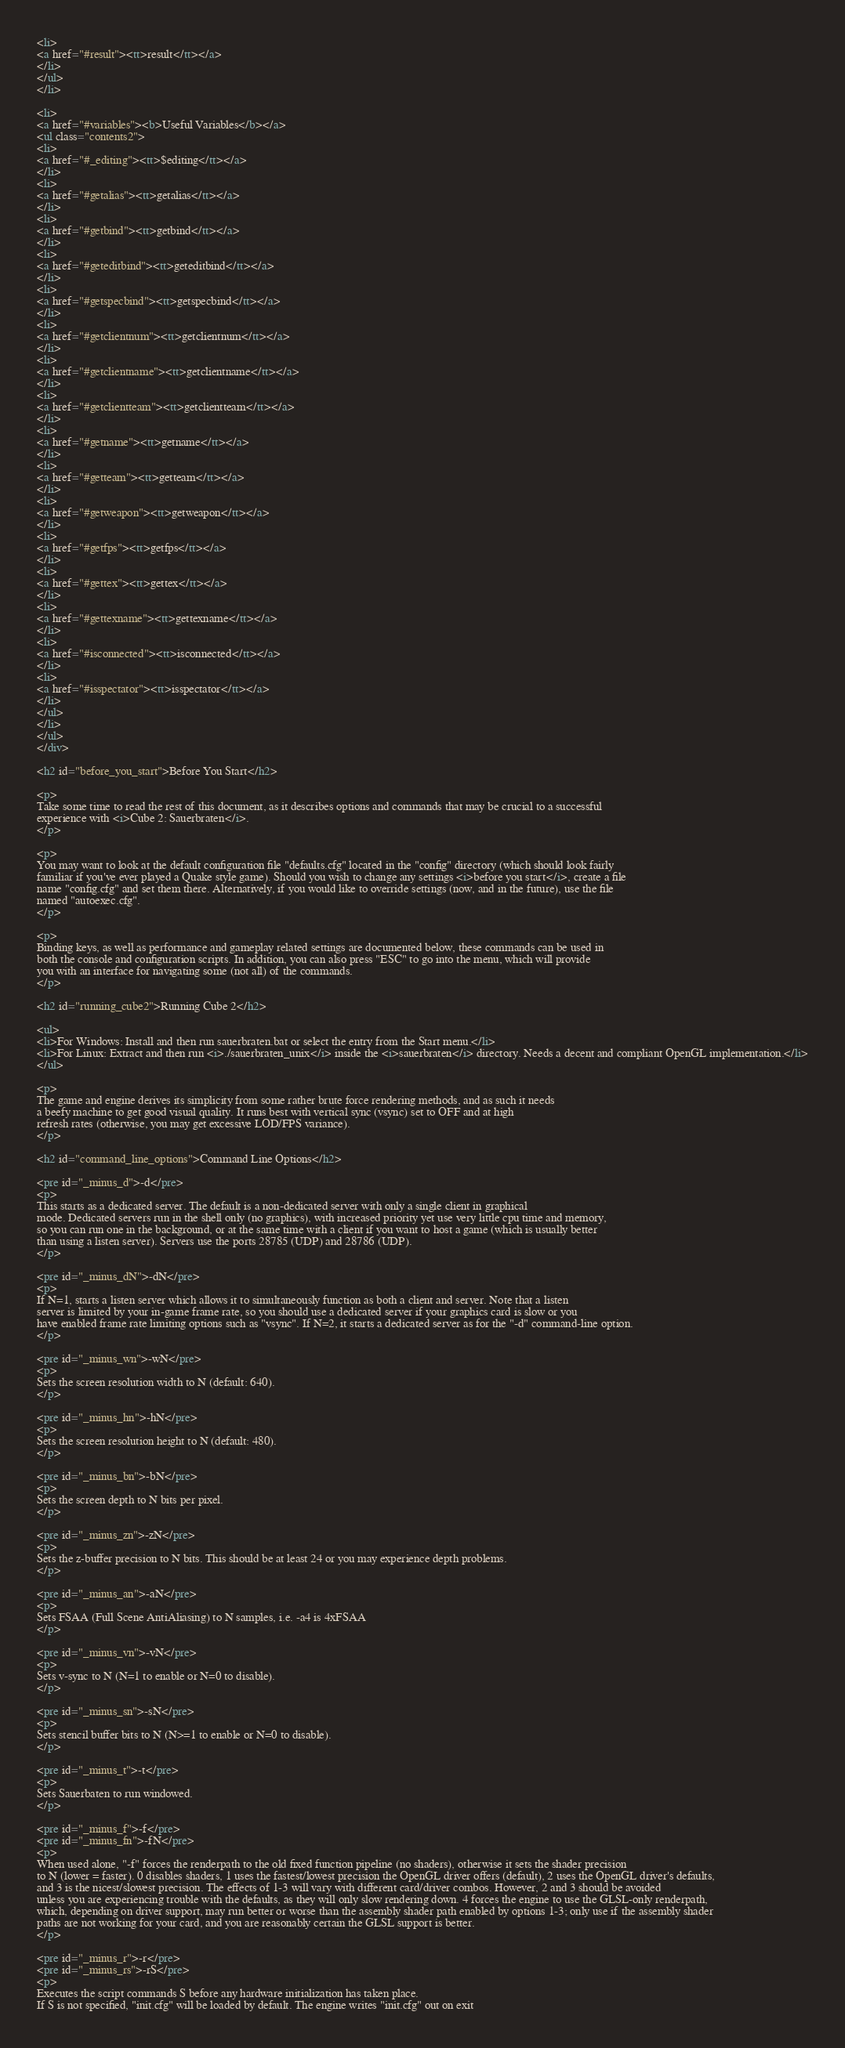Convert code to text. <code><loc_0><loc_0><loc_500><loc_500><_HTML_><li>
<a href="#result"><tt>result</tt></a>
</li>
</ul>
</li>

<li>
<a href="#variables"><b>Useful Variables</b></a>
<ul class="contents2">
<li>
<a href="#_editing"><tt>$editing</tt></a>
</li>
<li>
<a href="#getalias"><tt>getalias</tt></a>
</li>
<li>
<a href="#getbind"><tt>getbind</tt></a>
</li>
<li>
<a href="#geteditbind"><tt>geteditbind</tt></a>
</li>
<li>
<a href="#getspecbind"><tt>getspecbind</tt></a>
</li>
<li>
<a href="#getclientnum"><tt>getclientnum</tt></a>
</li>
<li>
<a href="#getclientname"><tt>getclientname</tt></a>
</li>
<li>
<a href="#getclientteam"><tt>getclientteam</tt></a>
</li>
<li>
<a href="#getname"><tt>getname</tt></a>
</li>
<li>
<a href="#getteam"><tt>getteam</tt></a>
</li>
<li>
<a href="#getweapon"><tt>getweapon</tt></a>
</li>
<li>
<a href="#getfps"><tt>getfps</tt></a>
</li>
<li>
<a href="#gettex"><tt>gettex</tt></a>
</li>
<li>
<a href="#gettexname"><tt>gettexname</tt></a>
</li>
<li>
<a href="#isconnected"><tt>isconnected</tt></a>
</li>
<li>
<a href="#isspectator"><tt>isspectator</tt></a>
</li>
</ul>
</li>
</ul>
</div>

<h2 id="before_you_start">Before You Start</h2>

<p>
Take some time to read the rest of this document, as it describes options and commands that may be crucial to a successful
experience with <i>Cube 2: Sauerbraten</i>.
</p>

<p>
You may want to look at the default configuration file "defaults.cfg" located in the "config" directory (which should look fairly
familiar if you've ever played a Quake style game). Should you wish to change any settings <i>before you start</i>, create a file
name "config.cfg" and set them there. Alternatively, if you would like to override settings (now, and in the future), use the file
named "autoexec.cfg".
</p>

<p>
Binding keys, as well as performance and gameplay related settings are documented below, these commands can be used in
both the console and configuration scripts. In addition, you can also press "ESC" to go into the menu, which will provide
you with an interface for navigating some (not all) of the commands.
</p>

<h2 id="running_cube2">Running Cube 2</h2>

<ul>
<li>For Windows: Install and then run sauerbraten.bat or select the entry from the Start menu.</li>
<li>For Linux: Extract and then run <i>./sauerbraten_unix</i> inside the <i>sauerbraten</i> directory. Needs a decent and compliant OpenGL implementation.</li>
</ul>

<p>
The game and engine derives its simplicity from some rather brute force rendering methods, and as such it needs 
a beefy machine to get good visual quality. It runs best with vertical sync (vsync) set to OFF and at high
refresh rates (otherwise, you may get excessive LOD/FPS variance).
</p>

<h2 id="command_line_options">Command Line Options</h2>

<pre id="_minus_d">-d</pre>
<p>
This starts as a dedicated server. The default is a non-dedicated server with only a single client in graphical
mode. Dedicated servers run in the shell only (no graphics), with increased priority yet use very little cpu time and memory,
so you can run one in the background, or at the same time with a client if you want to host a game (which is usually better 
than using a listen server). Servers use the ports 28785 (UDP) and 28786 (UDP).
</p>

<pre id="_minus_dN">-dN</pre>
<p>
If N=1, starts a listen server which allows it to simultaneously function as both a client and server. Note that a listen
server is limited by your in-game frame rate, so you should use a dedicated server if your graphics card is slow or you
have enabled frame rate limiting options such as "vsync". If N=2, it starts a dedicated server as for the "-d" command-line option.
</p>

<pre id="_minus_wn">-wN</pre>
<p>
Sets the screen resolution width to N (default: 640).
</p>

<pre id="_minus_hn">-hN</pre>
<p>
Sets the screen resolution height to N (default: 480).
</p>

<pre id="_minus_bn">-bN</pre>
<p>
Sets the screen depth to N bits per pixel.
</p>

<pre id="_minus_zn">-zN</pre>
<p>
Sets the z-buffer precision to N bits. This should be at least 24 or you may experience depth problems.
</p>

<pre id="_minus_an">-aN</pre>
<p>
Sets FSAA (Full Scene AntiAliasing) to N samples, i.e. -a4 is 4xFSAA
</p>

<pre id="_minus_vn">-vN</pre>
<p>
Sets v-sync to N (N=1 to enable or N=0 to disable).
</p>

<pre id="_minus_sn">-sN</pre>
<p>
Sets stencil buffer bits to N (N>=1 to enable or N=0 to disable).
</p> 

<pre id="_minus_t">-t</pre>
<p>
Sets Sauerbaten to run windowed.
</p>

<pre id="_minus_f">-f</pre>
<pre id="_minus_fn">-fN</pre>
<p>
When used alone, "-f" forces the renderpath to the old fixed function pipeline (no shaders), otherwise it sets the shader precision
to N (lower = faster). 0 disables shaders, 1 uses the fastest/lowest precision the OpenGL driver offers (default), 2 uses the OpenGL driver's defaults,
and 3 is the nicest/slowest precision. The effects of 1-3 will vary with different card/driver combos. However, 2 and 3 should be avoided
unless you are experiencing trouble with the defaults, as they will only slow rendering down. 4 forces the engine to use the GLSL-only renderpath,
which, depending on driver support, may run better or worse than the assembly shader path enabled by options 1-3; only use if the assembly shader
paths are not working for your card, and you are reasonably certain the GLSL support is better.
</p>

<pre id="_minus_r">-r</pre>
<pre id="_minus_rs">-rS</pre>
<p>
Executes the script commands S before any hardware initialization has taken place.
If S is not specified, "init.cfg" will be loaded by default. The engine writes "init.cfg" out on exit</code> 